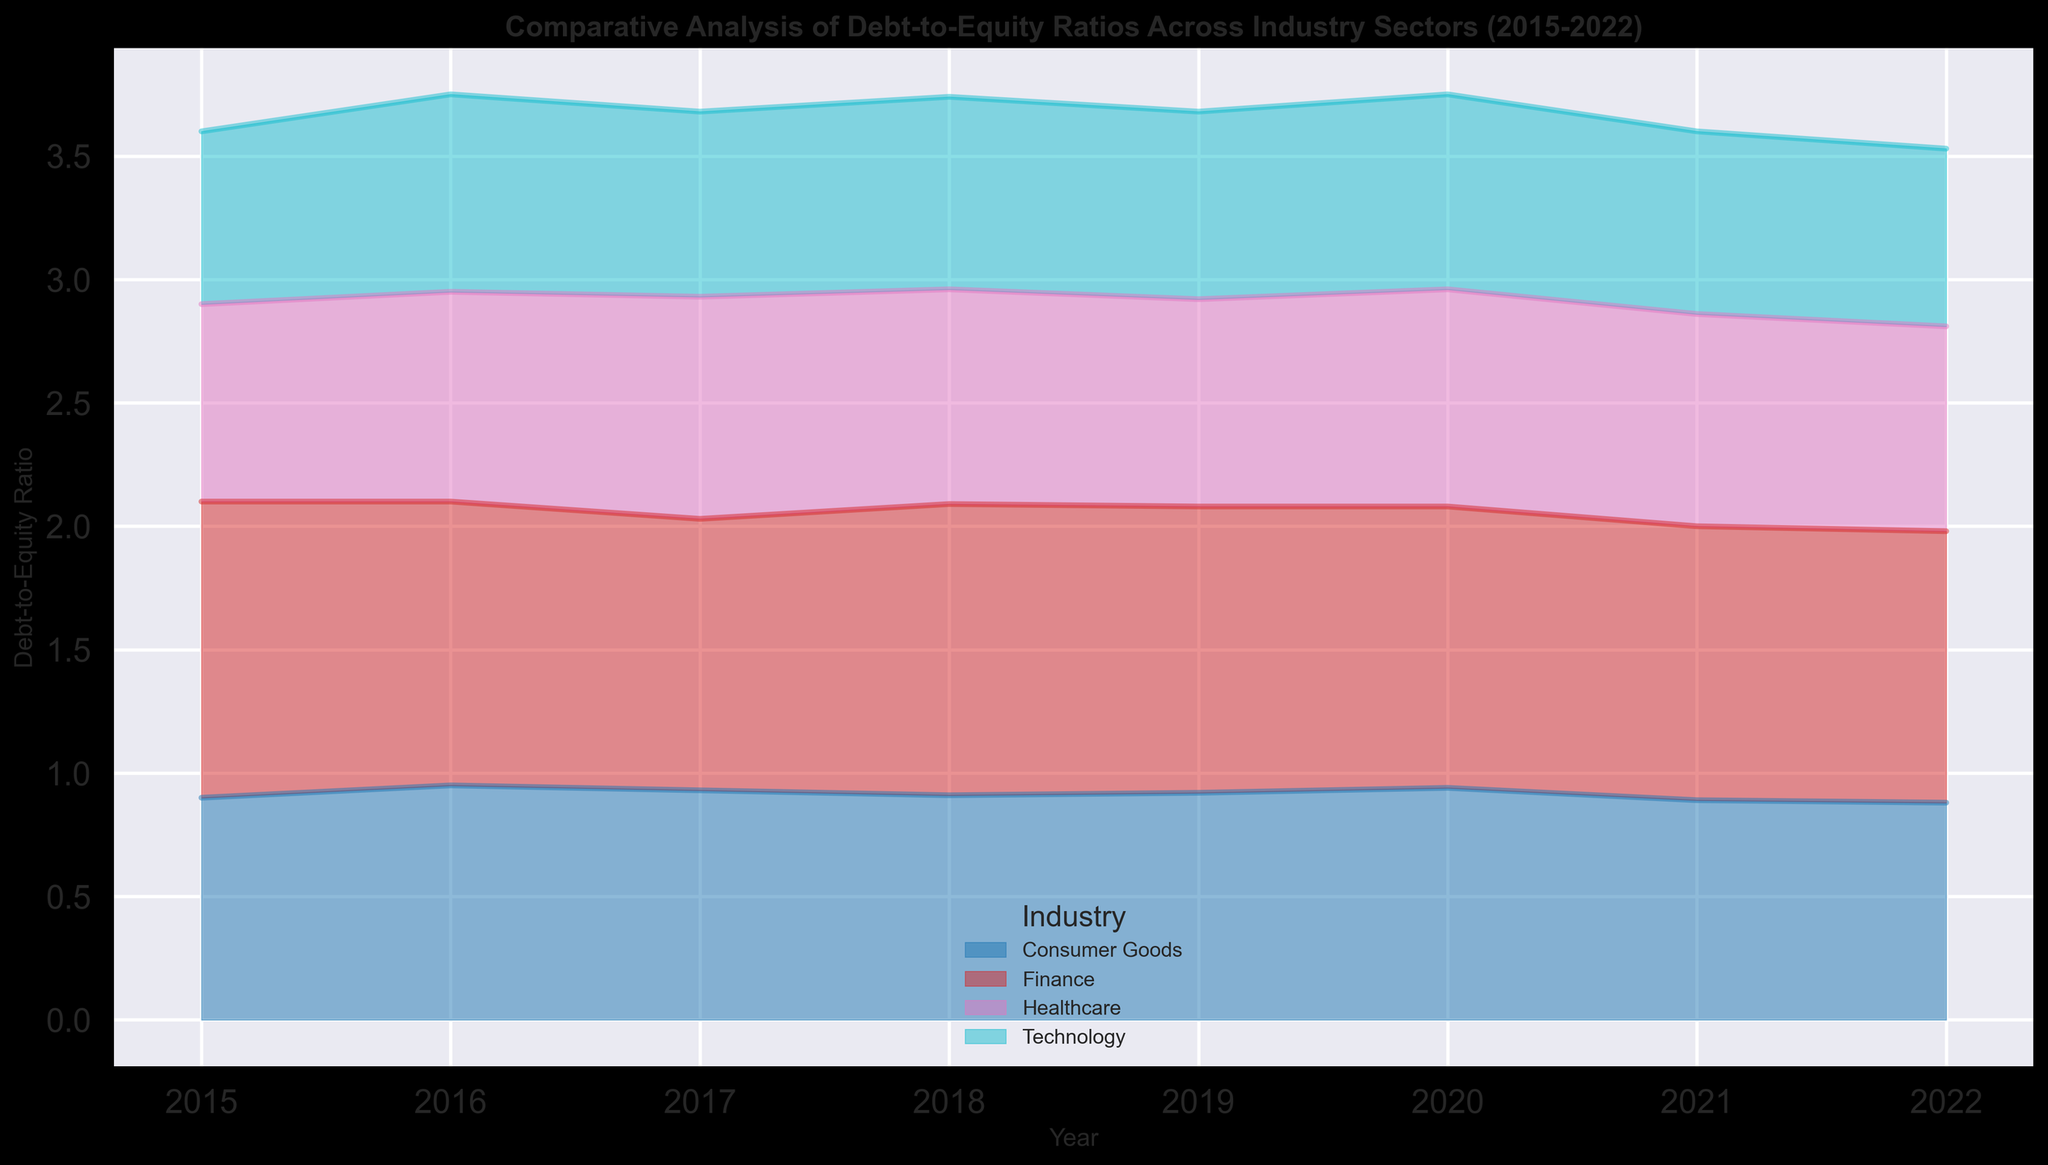Which industry sector had the highest Debt-to-Equity Ratio in 2015? From the figure, in 2015, the Finance sector has the highest height in the area chart, indicating the highest Debt-to-Equity Ratio.
Answer: Finance What is the trend of the Debt-to-Equity Ratio for the Healthcare sector from 2015 to 2022? From the figure, the area representing the Healthcare sector shows an increasing trend from 2015 to 2017, a slight decrease in 2018, a drop again in 2019, then fluctuating till 2022 where it decreases slightly.
Answer: Increasing until 2017, then fluctuating with a slight decrease by 2022 Between the Technology and Consumer Goods sectors, which had a lower Debt-to-Equity Ratio in 2017? By examining the figure, in 2017, the area of the Technology sector is lower than that of the Consumer Goods sector, indicating a lower Debt-to-Equity Ratio.
Answer: Technology What was the average Debt-to-Equity Ratio of the Finance sector for the years 2015 and 2022? From the figure, the values for the Finance sector in 2015 and 2022 are 1.2 and 1.1 respectively. The average can be calculated as (1.2 + 1.1) / 2 = 1.15.
Answer: 1.15 Which sector had the least variation in Debt-to-Equity Ratio from 2015 to 2022? From the figure, the Technology sector shows the least variation in the height of its area plot from 2015 to 2022.
Answer: Technology What is the difference in the Debt-to-Equity Ratio of the Finance sector between 2015 and 2022? The figure shows the Debt-to-Equity Ratio of the Finance sector being 1.2 in 2015 and 1.1 in 2022. The difference is 1.2 - 1.1 = 0.1.
Answer: 0.1 